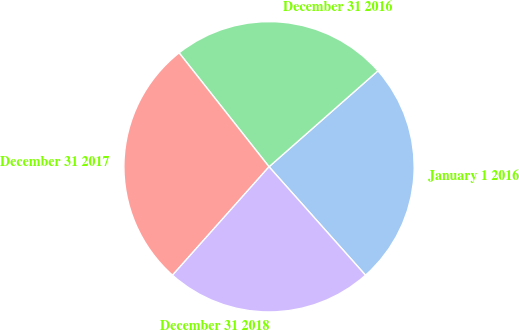Convert chart. <chart><loc_0><loc_0><loc_500><loc_500><pie_chart><fcel>January 1 2016<fcel>December 31 2016<fcel>December 31 2017<fcel>December 31 2018<nl><fcel>24.92%<fcel>24.14%<fcel>27.79%<fcel>23.15%<nl></chart> 